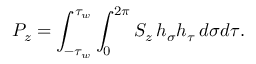<formula> <loc_0><loc_0><loc_500><loc_500>P _ { z } = \int _ { - \tau _ { w } } ^ { \tau _ { w } } \int _ { 0 } ^ { 2 \pi } S _ { z } \, h _ { \sigma } h _ { \tau } \, d \sigma d \tau .</formula> 